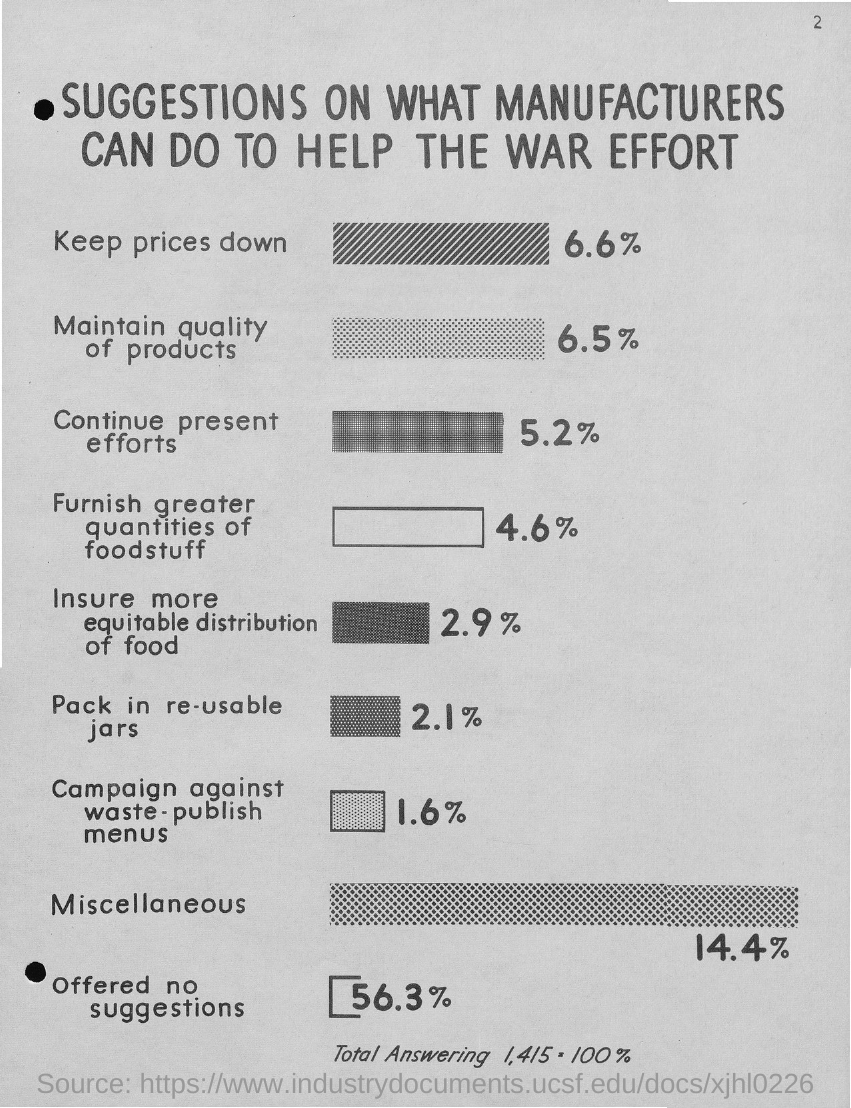What is the title of the document?
Provide a succinct answer. Suggestions on what Manufacturers can do to help the war effort. 